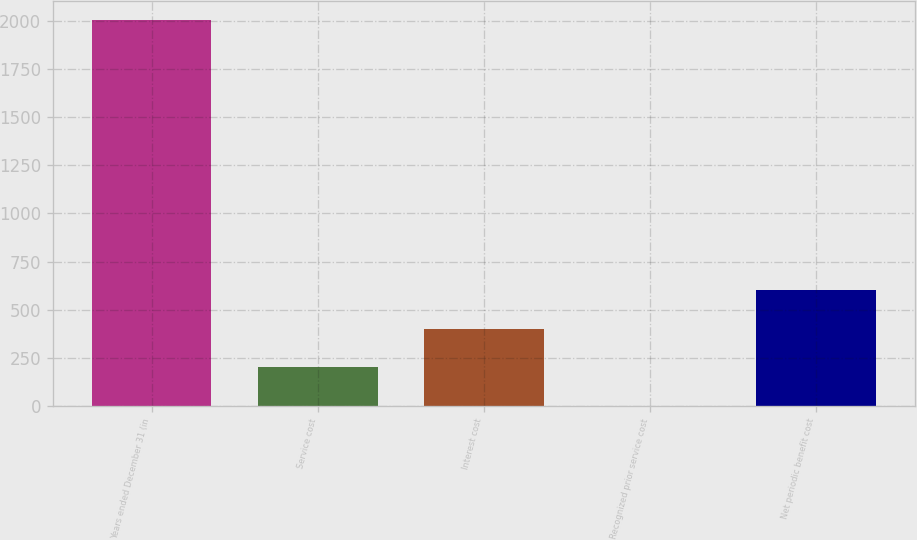Convert chart to OTSL. <chart><loc_0><loc_0><loc_500><loc_500><bar_chart><fcel>Years ended December 31 (in<fcel>Service cost<fcel>Interest cost<fcel>Recognized prior service cost<fcel>Net periodic benefit cost<nl><fcel>2004<fcel>200.58<fcel>400.96<fcel>0.2<fcel>601.34<nl></chart> 